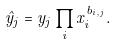<formula> <loc_0><loc_0><loc_500><loc_500>\hat { y } _ { j } = y _ { j } \prod _ { i } x _ { i } ^ { b _ { i , j } } .</formula> 